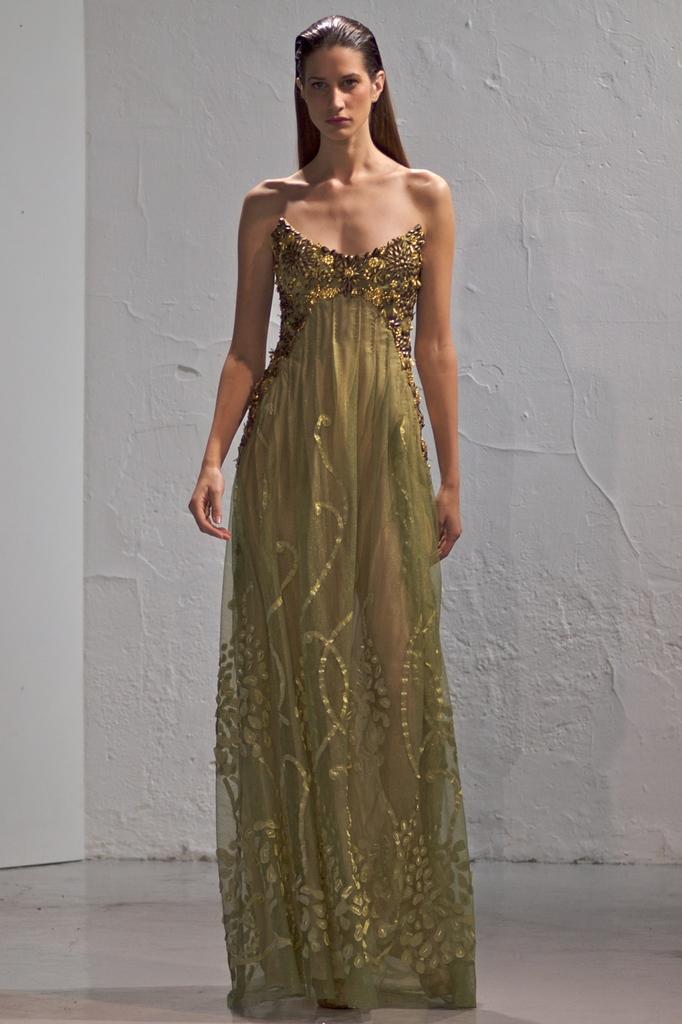Can you describe this image briefly? In this image, we can see a woman standing, in the background, we can see a wall. 